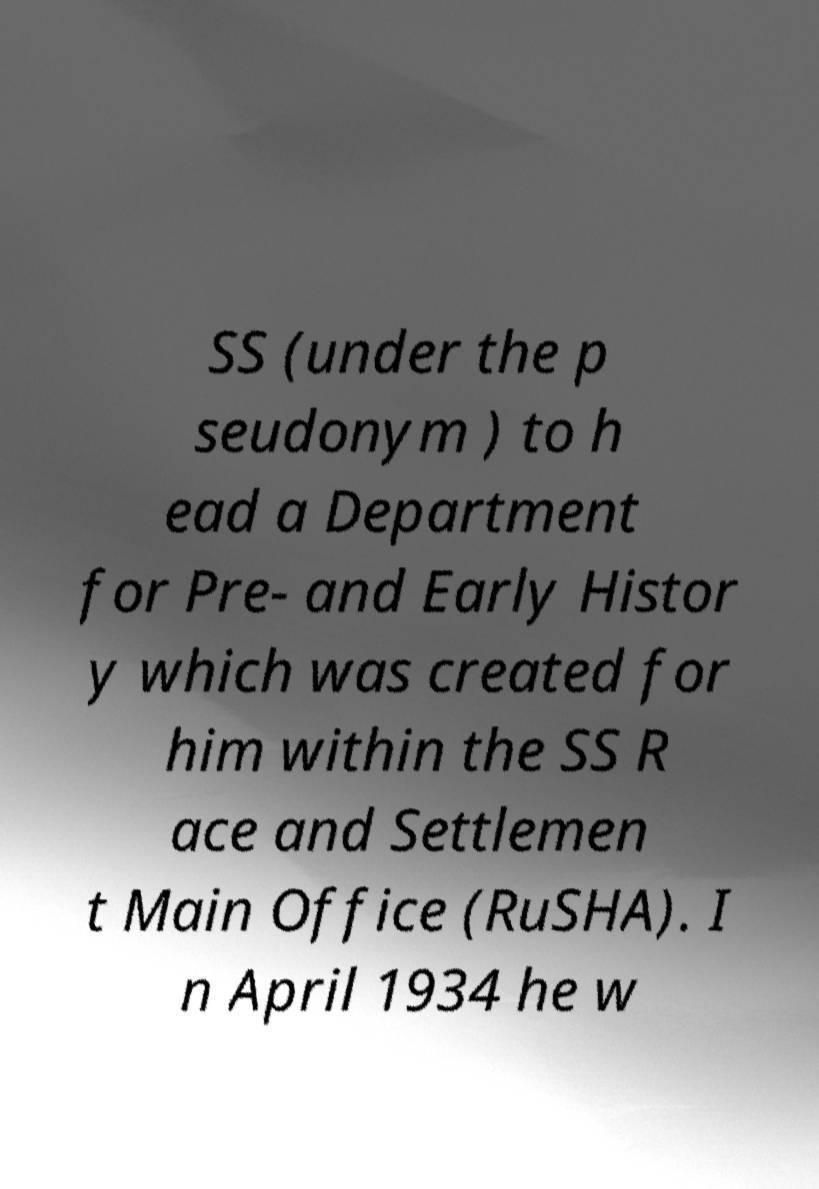Could you extract and type out the text from this image? SS (under the p seudonym ) to h ead a Department for Pre- and Early Histor y which was created for him within the SS R ace and Settlemen t Main Office (RuSHA). I n April 1934 he w 